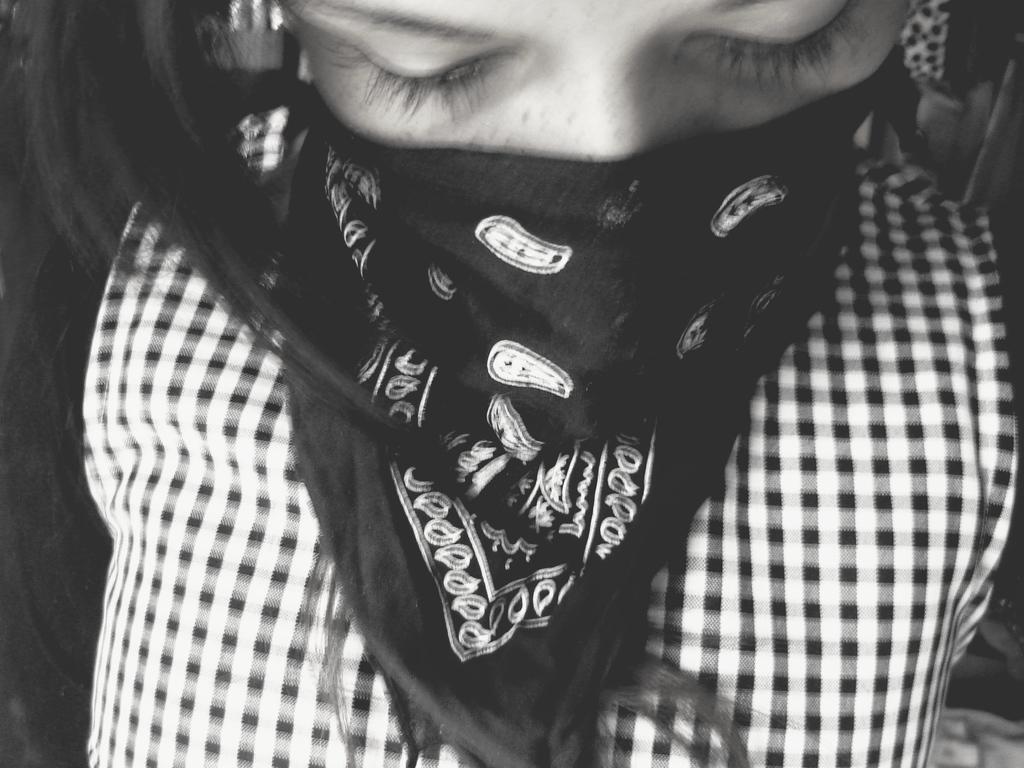Please provide a concise description of this image. In this picture there is a close view of the girl covering her face with black cloth and wearing checks type clothes. 